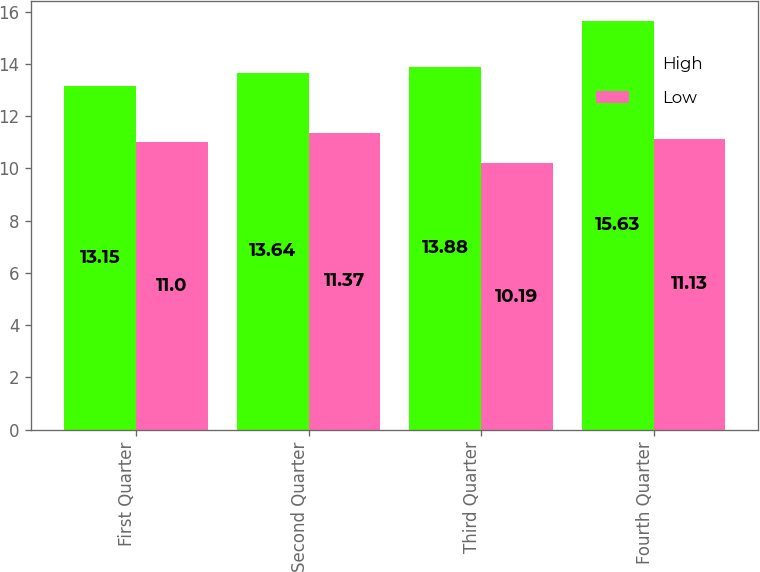Convert chart. <chart><loc_0><loc_0><loc_500><loc_500><stacked_bar_chart><ecel><fcel>First Quarter<fcel>Second Quarter<fcel>Third Quarter<fcel>Fourth Quarter<nl><fcel>High<fcel>13.15<fcel>13.64<fcel>13.88<fcel>15.63<nl><fcel>Low<fcel>11<fcel>11.37<fcel>10.19<fcel>11.13<nl></chart> 